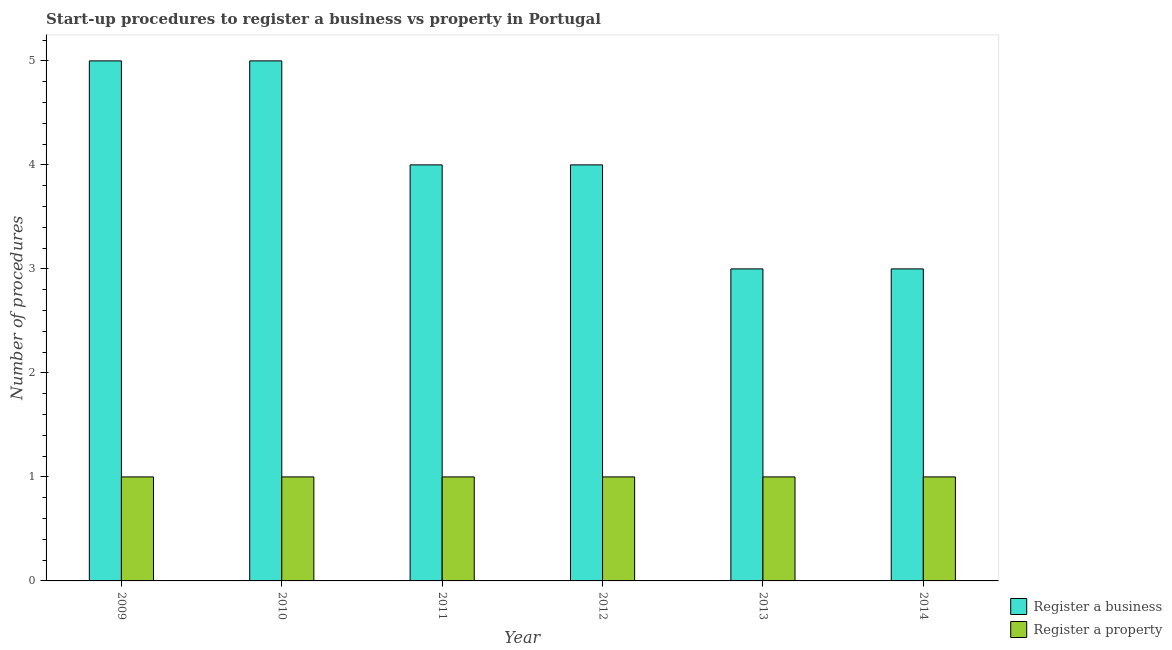How many different coloured bars are there?
Provide a succinct answer. 2. How many groups of bars are there?
Offer a terse response. 6. Are the number of bars per tick equal to the number of legend labels?
Your answer should be very brief. Yes. Are the number of bars on each tick of the X-axis equal?
Ensure brevity in your answer.  Yes. How many bars are there on the 2nd tick from the left?
Your answer should be very brief. 2. How many bars are there on the 1st tick from the right?
Offer a terse response. 2. What is the label of the 5th group of bars from the left?
Provide a succinct answer. 2013. What is the number of procedures to register a property in 2010?
Ensure brevity in your answer.  1. Across all years, what is the maximum number of procedures to register a business?
Ensure brevity in your answer.  5. Across all years, what is the minimum number of procedures to register a business?
Your answer should be very brief. 3. In which year was the number of procedures to register a property minimum?
Ensure brevity in your answer.  2009. What is the difference between the number of procedures to register a business in 2009 and that in 2012?
Your answer should be compact. 1. What is the difference between the number of procedures to register a business in 2011 and the number of procedures to register a property in 2013?
Provide a short and direct response. 1. In the year 2009, what is the difference between the number of procedures to register a business and number of procedures to register a property?
Offer a very short reply. 0. In how many years, is the number of procedures to register a property greater than 2?
Give a very brief answer. 0. What is the ratio of the number of procedures to register a property in 2011 to that in 2013?
Make the answer very short. 1. Is the number of procedures to register a property in 2010 less than that in 2013?
Offer a very short reply. No. What is the difference between the highest and the lowest number of procedures to register a business?
Keep it short and to the point. 2. In how many years, is the number of procedures to register a business greater than the average number of procedures to register a business taken over all years?
Your answer should be compact. 2. Is the sum of the number of procedures to register a property in 2010 and 2012 greater than the maximum number of procedures to register a business across all years?
Provide a short and direct response. Yes. What does the 1st bar from the left in 2014 represents?
Your answer should be very brief. Register a business. What does the 2nd bar from the right in 2010 represents?
Ensure brevity in your answer.  Register a business. How many bars are there?
Your answer should be compact. 12. Are all the bars in the graph horizontal?
Provide a short and direct response. No. How many years are there in the graph?
Your answer should be compact. 6. Where does the legend appear in the graph?
Ensure brevity in your answer.  Bottom right. How many legend labels are there?
Your answer should be very brief. 2. What is the title of the graph?
Your answer should be very brief. Start-up procedures to register a business vs property in Portugal. What is the label or title of the X-axis?
Your response must be concise. Year. What is the label or title of the Y-axis?
Your answer should be very brief. Number of procedures. What is the Number of procedures of Register a property in 2012?
Offer a terse response. 1. What is the Number of procedures in Register a property in 2013?
Offer a terse response. 1. What is the Number of procedures in Register a business in 2014?
Give a very brief answer. 3. Across all years, what is the maximum Number of procedures of Register a property?
Keep it short and to the point. 1. Across all years, what is the minimum Number of procedures of Register a business?
Ensure brevity in your answer.  3. Across all years, what is the minimum Number of procedures of Register a property?
Provide a succinct answer. 1. What is the total Number of procedures of Register a business in the graph?
Your answer should be compact. 24. What is the difference between the Number of procedures in Register a property in 2009 and that in 2010?
Your answer should be compact. 0. What is the difference between the Number of procedures in Register a business in 2009 and that in 2012?
Offer a terse response. 1. What is the difference between the Number of procedures of Register a business in 2009 and that in 2013?
Make the answer very short. 2. What is the difference between the Number of procedures in Register a property in 2009 and that in 2014?
Your answer should be compact. 0. What is the difference between the Number of procedures in Register a property in 2010 and that in 2012?
Give a very brief answer. 0. What is the difference between the Number of procedures of Register a property in 2010 and that in 2013?
Ensure brevity in your answer.  0. What is the difference between the Number of procedures in Register a business in 2010 and that in 2014?
Provide a succinct answer. 2. What is the difference between the Number of procedures of Register a property in 2010 and that in 2014?
Keep it short and to the point. 0. What is the difference between the Number of procedures of Register a business in 2011 and that in 2012?
Your answer should be very brief. 0. What is the difference between the Number of procedures of Register a business in 2011 and that in 2013?
Ensure brevity in your answer.  1. What is the difference between the Number of procedures in Register a property in 2011 and that in 2014?
Ensure brevity in your answer.  0. What is the difference between the Number of procedures of Register a business in 2012 and that in 2013?
Your answer should be compact. 1. What is the difference between the Number of procedures in Register a property in 2012 and that in 2014?
Offer a terse response. 0. What is the difference between the Number of procedures in Register a property in 2013 and that in 2014?
Give a very brief answer. 0. What is the difference between the Number of procedures in Register a business in 2009 and the Number of procedures in Register a property in 2011?
Give a very brief answer. 4. What is the difference between the Number of procedures in Register a business in 2009 and the Number of procedures in Register a property in 2013?
Your answer should be very brief. 4. What is the difference between the Number of procedures of Register a business in 2010 and the Number of procedures of Register a property in 2011?
Ensure brevity in your answer.  4. What is the difference between the Number of procedures in Register a business in 2010 and the Number of procedures in Register a property in 2012?
Make the answer very short. 4. What is the difference between the Number of procedures in Register a business in 2010 and the Number of procedures in Register a property in 2013?
Provide a short and direct response. 4. What is the difference between the Number of procedures of Register a business in 2011 and the Number of procedures of Register a property in 2012?
Keep it short and to the point. 3. What is the difference between the Number of procedures of Register a business in 2011 and the Number of procedures of Register a property in 2013?
Provide a short and direct response. 3. What is the difference between the Number of procedures of Register a business in 2011 and the Number of procedures of Register a property in 2014?
Keep it short and to the point. 3. What is the difference between the Number of procedures in Register a business in 2013 and the Number of procedures in Register a property in 2014?
Offer a very short reply. 2. What is the average Number of procedures in Register a business per year?
Ensure brevity in your answer.  4. What is the average Number of procedures of Register a property per year?
Offer a very short reply. 1. In the year 2009, what is the difference between the Number of procedures in Register a business and Number of procedures in Register a property?
Offer a terse response. 4. In the year 2011, what is the difference between the Number of procedures of Register a business and Number of procedures of Register a property?
Ensure brevity in your answer.  3. In the year 2014, what is the difference between the Number of procedures in Register a business and Number of procedures in Register a property?
Provide a short and direct response. 2. What is the ratio of the Number of procedures in Register a property in 2009 to that in 2011?
Ensure brevity in your answer.  1. What is the ratio of the Number of procedures of Register a business in 2009 to that in 2012?
Offer a terse response. 1.25. What is the ratio of the Number of procedures in Register a property in 2009 to that in 2012?
Make the answer very short. 1. What is the ratio of the Number of procedures in Register a property in 2009 to that in 2014?
Give a very brief answer. 1. What is the ratio of the Number of procedures in Register a business in 2010 to that in 2011?
Ensure brevity in your answer.  1.25. What is the ratio of the Number of procedures of Register a business in 2010 to that in 2012?
Offer a terse response. 1.25. What is the ratio of the Number of procedures in Register a property in 2010 to that in 2012?
Keep it short and to the point. 1. What is the ratio of the Number of procedures in Register a property in 2010 to that in 2013?
Offer a terse response. 1. What is the ratio of the Number of procedures of Register a business in 2010 to that in 2014?
Offer a very short reply. 1.67. What is the ratio of the Number of procedures of Register a property in 2010 to that in 2014?
Make the answer very short. 1. What is the ratio of the Number of procedures of Register a business in 2011 to that in 2012?
Give a very brief answer. 1. What is the ratio of the Number of procedures in Register a property in 2011 to that in 2012?
Ensure brevity in your answer.  1. What is the ratio of the Number of procedures of Register a business in 2011 to that in 2013?
Offer a terse response. 1.33. What is the ratio of the Number of procedures of Register a business in 2011 to that in 2014?
Keep it short and to the point. 1.33. What is the ratio of the Number of procedures in Register a business in 2012 to that in 2013?
Provide a succinct answer. 1.33. What is the ratio of the Number of procedures in Register a property in 2012 to that in 2013?
Your answer should be very brief. 1. What is the ratio of the Number of procedures in Register a business in 2013 to that in 2014?
Offer a very short reply. 1. What is the difference between the highest and the lowest Number of procedures in Register a business?
Your answer should be very brief. 2. 